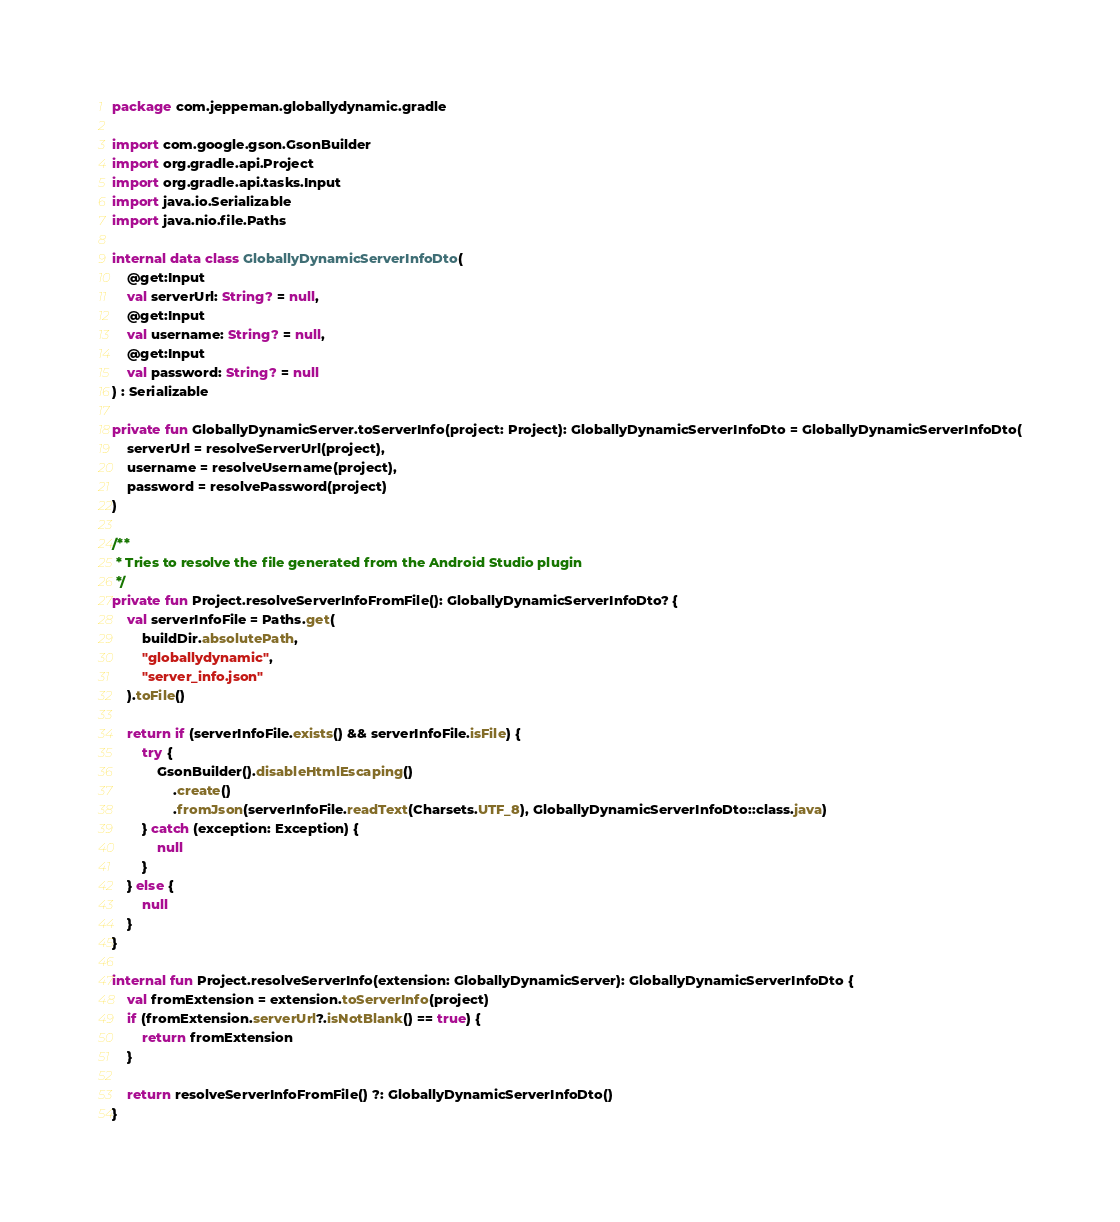<code> <loc_0><loc_0><loc_500><loc_500><_Kotlin_>package com.jeppeman.globallydynamic.gradle

import com.google.gson.GsonBuilder
import org.gradle.api.Project
import org.gradle.api.tasks.Input
import java.io.Serializable
import java.nio.file.Paths

internal data class GloballyDynamicServerInfoDto(
    @get:Input
    val serverUrl: String? = null,
    @get:Input
    val username: String? = null,
    @get:Input
    val password: String? = null
) : Serializable

private fun GloballyDynamicServer.toServerInfo(project: Project): GloballyDynamicServerInfoDto = GloballyDynamicServerInfoDto(
    serverUrl = resolveServerUrl(project),
    username = resolveUsername(project),
    password = resolvePassword(project)
)

/**
 * Tries to resolve the file generated from the Android Studio plugin
 */
private fun Project.resolveServerInfoFromFile(): GloballyDynamicServerInfoDto? {
    val serverInfoFile = Paths.get(
        buildDir.absolutePath,
        "globallydynamic",
        "server_info.json"
    ).toFile()

    return if (serverInfoFile.exists() && serverInfoFile.isFile) {
        try {
            GsonBuilder().disableHtmlEscaping()
                .create()
                .fromJson(serverInfoFile.readText(Charsets.UTF_8), GloballyDynamicServerInfoDto::class.java)
        } catch (exception: Exception) {
            null
        }
    } else {
        null
    }
}

internal fun Project.resolveServerInfo(extension: GloballyDynamicServer): GloballyDynamicServerInfoDto {
    val fromExtension = extension.toServerInfo(project)
    if (fromExtension.serverUrl?.isNotBlank() == true) {
        return fromExtension
    }

    return resolveServerInfoFromFile() ?: GloballyDynamicServerInfoDto()
}</code> 